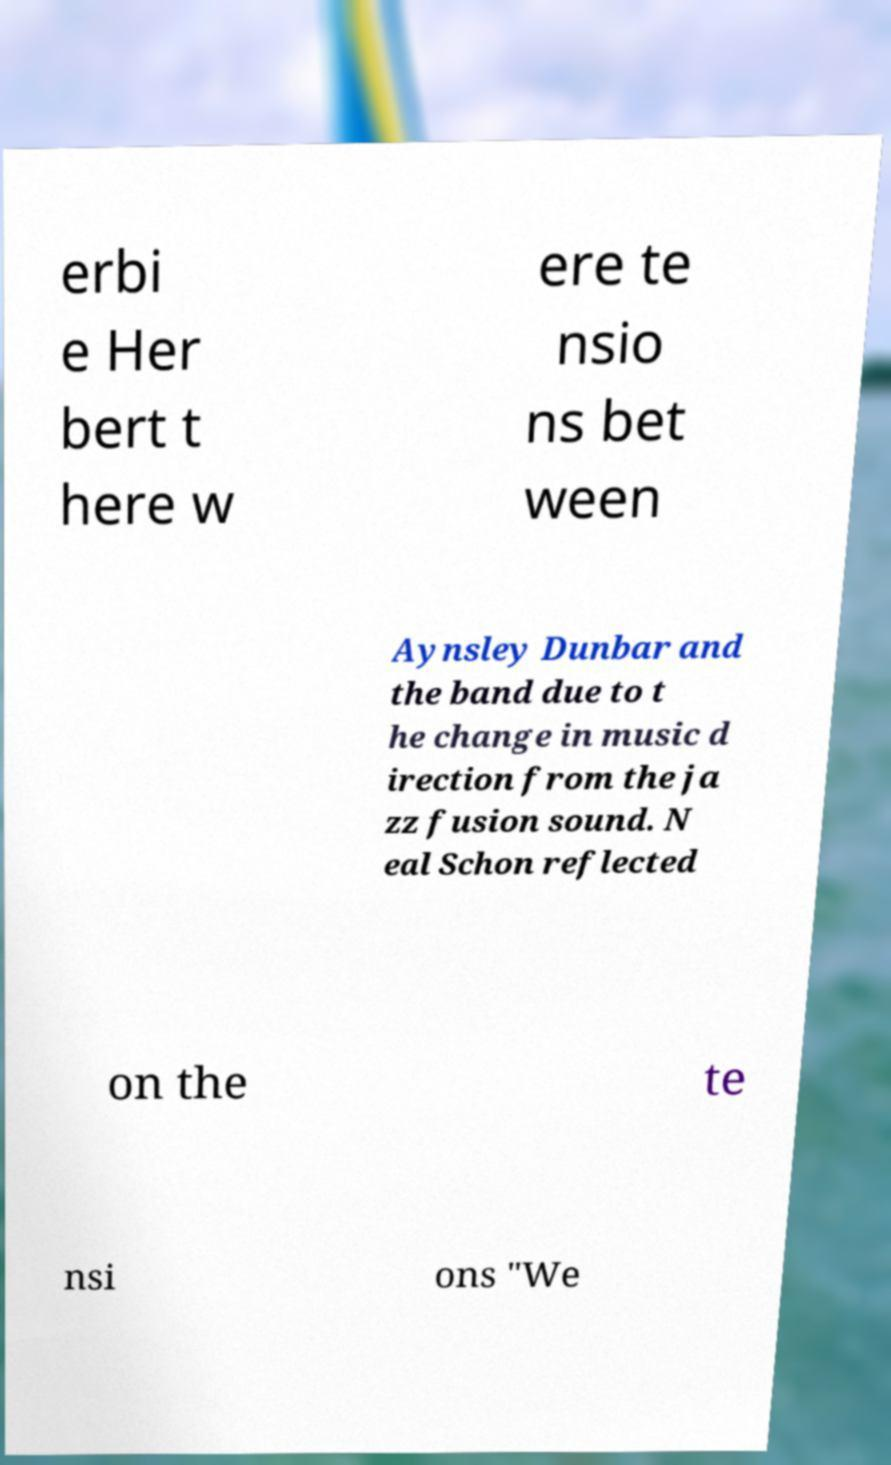Can you read and provide the text displayed in the image?This photo seems to have some interesting text. Can you extract and type it out for me? erbi e Her bert t here w ere te nsio ns bet ween Aynsley Dunbar and the band due to t he change in music d irection from the ja zz fusion sound. N eal Schon reflected on the te nsi ons "We 